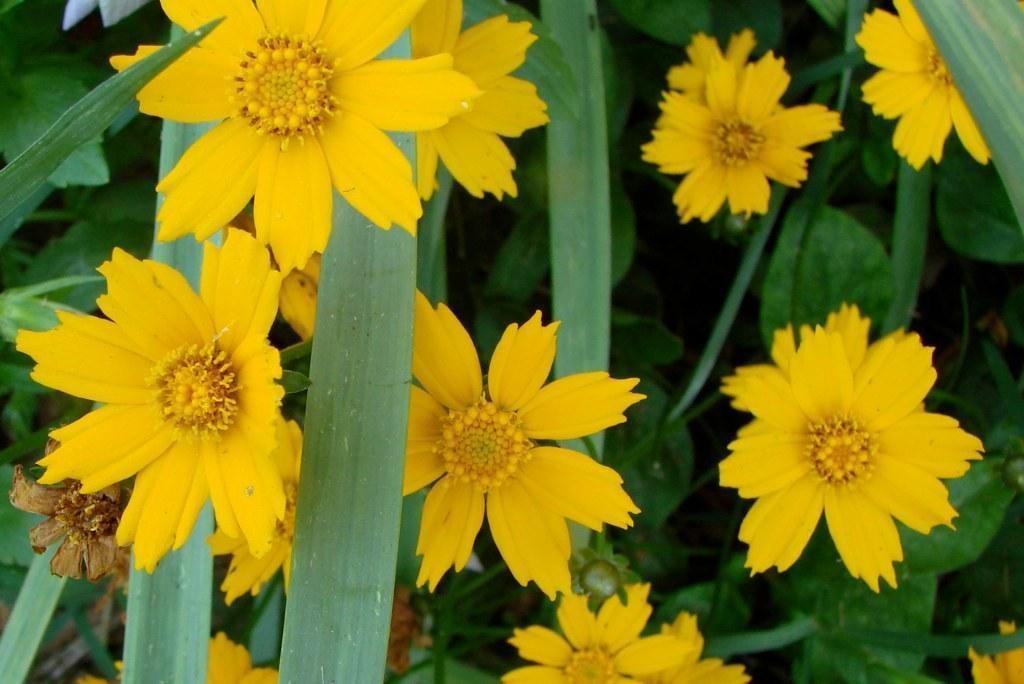In one or two sentences, can you explain what this image depicts? It is a zoomed in picture of yellow color flowers and also the leaves. 